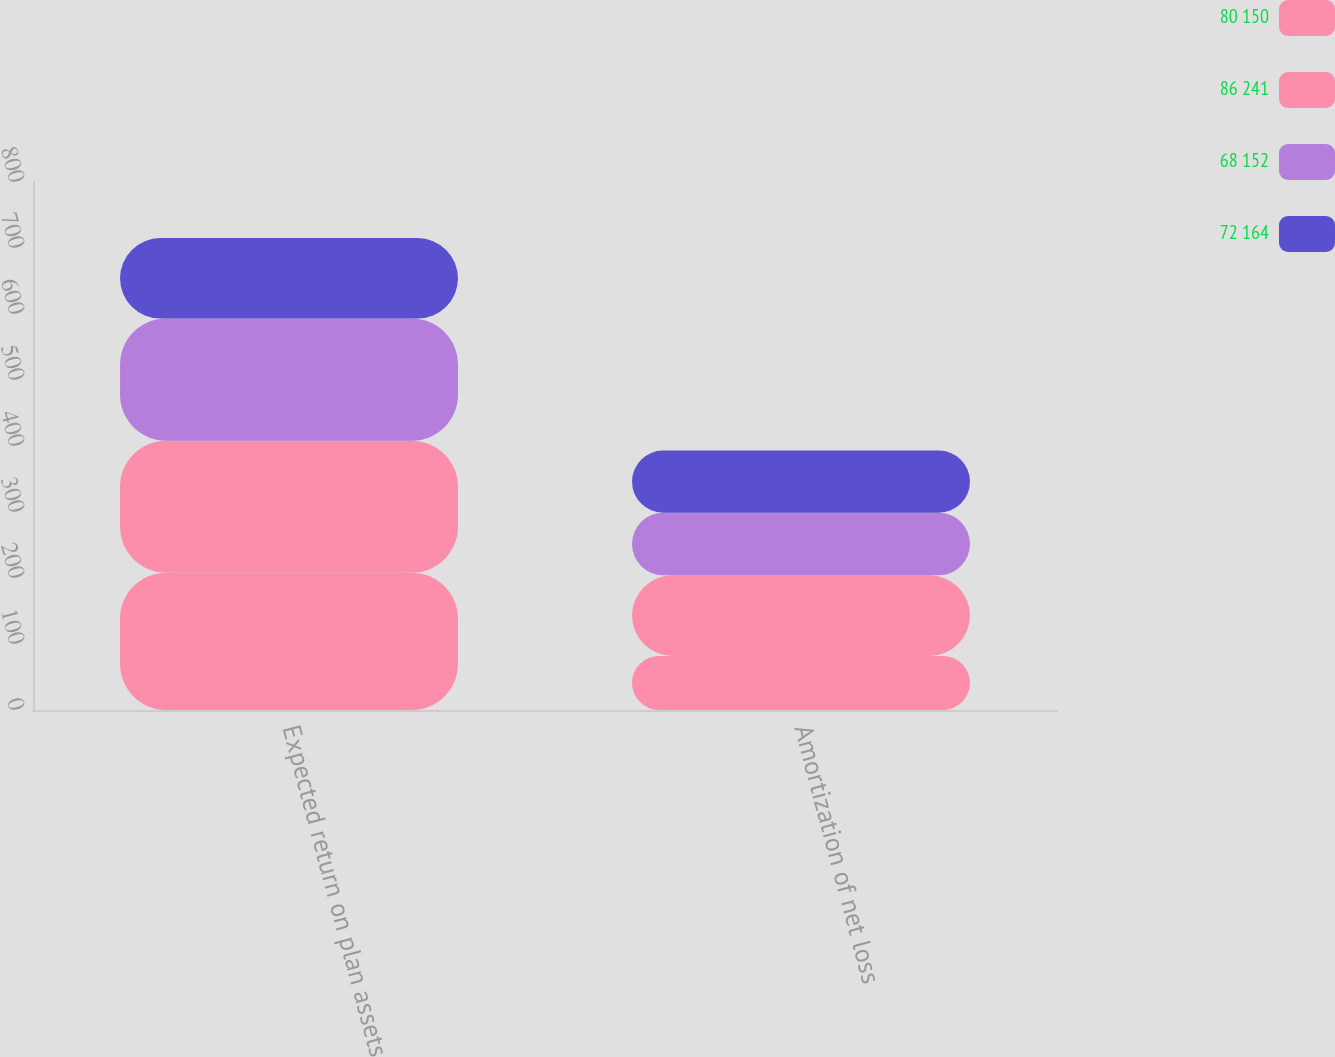<chart> <loc_0><loc_0><loc_500><loc_500><stacked_bar_chart><ecel><fcel>Expected return on plan assets<fcel>Amortization of net loss<nl><fcel>80 150<fcel>208<fcel>82<nl><fcel>86 241<fcel>200<fcel>122<nl><fcel>68 152<fcel>185<fcel>95<nl><fcel>72 164<fcel>122<fcel>94<nl></chart> 